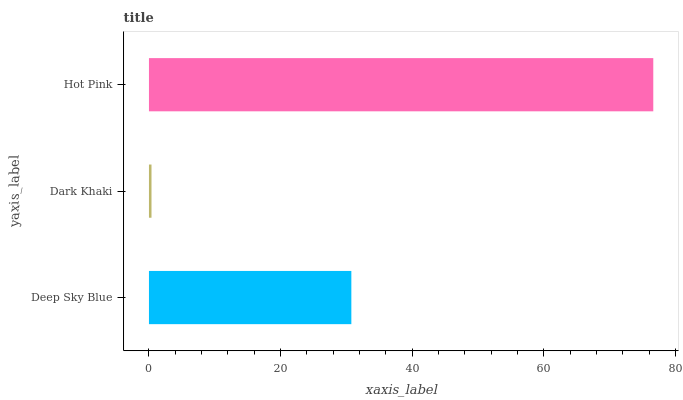Is Dark Khaki the minimum?
Answer yes or no. Yes. Is Hot Pink the maximum?
Answer yes or no. Yes. Is Hot Pink the minimum?
Answer yes or no. No. Is Dark Khaki the maximum?
Answer yes or no. No. Is Hot Pink greater than Dark Khaki?
Answer yes or no. Yes. Is Dark Khaki less than Hot Pink?
Answer yes or no. Yes. Is Dark Khaki greater than Hot Pink?
Answer yes or no. No. Is Hot Pink less than Dark Khaki?
Answer yes or no. No. Is Deep Sky Blue the high median?
Answer yes or no. Yes. Is Deep Sky Blue the low median?
Answer yes or no. Yes. Is Dark Khaki the high median?
Answer yes or no. No. Is Dark Khaki the low median?
Answer yes or no. No. 